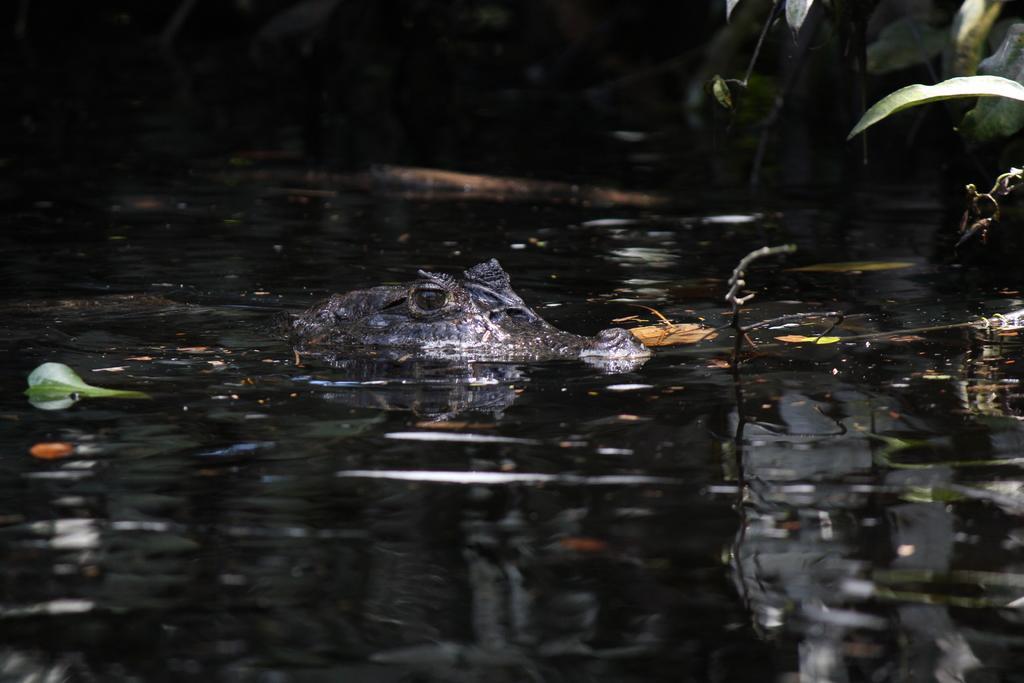How would you summarize this image in a sentence or two? In this image we can see a crocodile in the water. In the background, we can see group of leaves. 